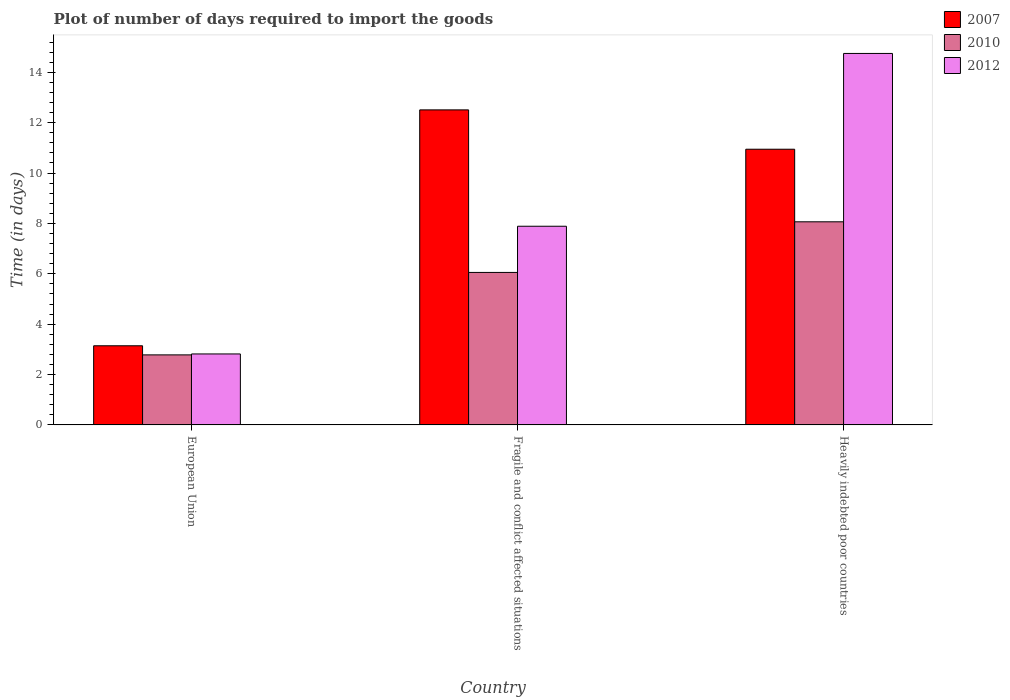Are the number of bars on each tick of the X-axis equal?
Keep it short and to the point. Yes. How many bars are there on the 1st tick from the right?
Offer a terse response. 3. What is the label of the 2nd group of bars from the left?
Make the answer very short. Fragile and conflict affected situations. What is the time required to import goods in 2007 in Heavily indebted poor countries?
Keep it short and to the point. 10.95. Across all countries, what is the maximum time required to import goods in 2012?
Your answer should be very brief. 14.75. Across all countries, what is the minimum time required to import goods in 2012?
Give a very brief answer. 2.82. In which country was the time required to import goods in 2010 maximum?
Ensure brevity in your answer.  Heavily indebted poor countries. What is the total time required to import goods in 2010 in the graph?
Ensure brevity in your answer.  16.9. What is the difference between the time required to import goods in 2012 in European Union and that in Fragile and conflict affected situations?
Provide a short and direct response. -5.07. What is the difference between the time required to import goods in 2012 in Fragile and conflict affected situations and the time required to import goods in 2007 in European Union?
Offer a terse response. 4.75. What is the average time required to import goods in 2007 per country?
Provide a succinct answer. 8.87. What is the difference between the time required to import goods of/in 2012 and time required to import goods of/in 2007 in Heavily indebted poor countries?
Keep it short and to the point. 3.8. What is the ratio of the time required to import goods in 2007 in Fragile and conflict affected situations to that in Heavily indebted poor countries?
Offer a terse response. 1.14. Is the time required to import goods in 2007 in European Union less than that in Fragile and conflict affected situations?
Make the answer very short. Yes. Is the difference between the time required to import goods in 2012 in European Union and Heavily indebted poor countries greater than the difference between the time required to import goods in 2007 in European Union and Heavily indebted poor countries?
Offer a very short reply. No. What is the difference between the highest and the second highest time required to import goods in 2007?
Offer a very short reply. 7.8. What is the difference between the highest and the lowest time required to import goods in 2012?
Your response must be concise. 11.93. In how many countries, is the time required to import goods in 2012 greater than the average time required to import goods in 2012 taken over all countries?
Provide a short and direct response. 1. What does the 1st bar from the left in Heavily indebted poor countries represents?
Provide a succinct answer. 2007. Are the values on the major ticks of Y-axis written in scientific E-notation?
Give a very brief answer. No. Does the graph contain any zero values?
Make the answer very short. No. How many legend labels are there?
Your response must be concise. 3. How are the legend labels stacked?
Provide a short and direct response. Vertical. What is the title of the graph?
Offer a terse response. Plot of number of days required to import the goods. Does "1977" appear as one of the legend labels in the graph?
Your answer should be compact. No. What is the label or title of the Y-axis?
Make the answer very short. Time (in days). What is the Time (in days) in 2007 in European Union?
Keep it short and to the point. 3.14. What is the Time (in days) of 2010 in European Union?
Your response must be concise. 2.78. What is the Time (in days) of 2012 in European Union?
Ensure brevity in your answer.  2.82. What is the Time (in days) in 2007 in Fragile and conflict affected situations?
Provide a short and direct response. 12.51. What is the Time (in days) of 2010 in Fragile and conflict affected situations?
Ensure brevity in your answer.  6.05. What is the Time (in days) in 2012 in Fragile and conflict affected situations?
Keep it short and to the point. 7.89. What is the Time (in days) of 2007 in Heavily indebted poor countries?
Ensure brevity in your answer.  10.95. What is the Time (in days) in 2010 in Heavily indebted poor countries?
Your answer should be compact. 8.06. What is the Time (in days) in 2012 in Heavily indebted poor countries?
Your answer should be very brief. 14.75. Across all countries, what is the maximum Time (in days) in 2007?
Ensure brevity in your answer.  12.51. Across all countries, what is the maximum Time (in days) in 2010?
Keep it short and to the point. 8.06. Across all countries, what is the maximum Time (in days) in 2012?
Your response must be concise. 14.75. Across all countries, what is the minimum Time (in days) in 2007?
Ensure brevity in your answer.  3.14. Across all countries, what is the minimum Time (in days) of 2010?
Ensure brevity in your answer.  2.78. Across all countries, what is the minimum Time (in days) of 2012?
Ensure brevity in your answer.  2.82. What is the total Time (in days) in 2007 in the graph?
Offer a terse response. 26.6. What is the total Time (in days) in 2010 in the graph?
Give a very brief answer. 16.9. What is the total Time (in days) of 2012 in the graph?
Ensure brevity in your answer.  25.46. What is the difference between the Time (in days) of 2007 in European Union and that in Fragile and conflict affected situations?
Your answer should be very brief. -9.37. What is the difference between the Time (in days) in 2010 in European Union and that in Fragile and conflict affected situations?
Offer a terse response. -3.27. What is the difference between the Time (in days) in 2012 in European Union and that in Fragile and conflict affected situations?
Provide a succinct answer. -5.07. What is the difference between the Time (in days) in 2007 in European Union and that in Heavily indebted poor countries?
Provide a succinct answer. -7.8. What is the difference between the Time (in days) in 2010 in European Union and that in Heavily indebted poor countries?
Your answer should be very brief. -5.28. What is the difference between the Time (in days) of 2012 in European Union and that in Heavily indebted poor countries?
Your response must be concise. -11.93. What is the difference between the Time (in days) of 2007 in Fragile and conflict affected situations and that in Heavily indebted poor countries?
Ensure brevity in your answer.  1.56. What is the difference between the Time (in days) of 2010 in Fragile and conflict affected situations and that in Heavily indebted poor countries?
Your answer should be compact. -2.01. What is the difference between the Time (in days) of 2012 in Fragile and conflict affected situations and that in Heavily indebted poor countries?
Give a very brief answer. -6.86. What is the difference between the Time (in days) in 2007 in European Union and the Time (in days) in 2010 in Fragile and conflict affected situations?
Provide a succinct answer. -2.91. What is the difference between the Time (in days) in 2007 in European Union and the Time (in days) in 2012 in Fragile and conflict affected situations?
Your answer should be very brief. -4.75. What is the difference between the Time (in days) in 2010 in European Union and the Time (in days) in 2012 in Fragile and conflict affected situations?
Your response must be concise. -5.11. What is the difference between the Time (in days) of 2007 in European Union and the Time (in days) of 2010 in Heavily indebted poor countries?
Provide a succinct answer. -4.92. What is the difference between the Time (in days) in 2007 in European Union and the Time (in days) in 2012 in Heavily indebted poor countries?
Ensure brevity in your answer.  -11.61. What is the difference between the Time (in days) of 2010 in European Union and the Time (in days) of 2012 in Heavily indebted poor countries?
Your answer should be compact. -11.97. What is the difference between the Time (in days) of 2007 in Fragile and conflict affected situations and the Time (in days) of 2010 in Heavily indebted poor countries?
Keep it short and to the point. 4.44. What is the difference between the Time (in days) of 2007 in Fragile and conflict affected situations and the Time (in days) of 2012 in Heavily indebted poor countries?
Give a very brief answer. -2.24. What is the difference between the Time (in days) of 2010 in Fragile and conflict affected situations and the Time (in days) of 2012 in Heavily indebted poor countries?
Keep it short and to the point. -8.7. What is the average Time (in days) in 2007 per country?
Offer a very short reply. 8.87. What is the average Time (in days) of 2010 per country?
Give a very brief answer. 5.63. What is the average Time (in days) in 2012 per country?
Offer a very short reply. 8.49. What is the difference between the Time (in days) of 2007 and Time (in days) of 2010 in European Union?
Your answer should be compact. 0.36. What is the difference between the Time (in days) of 2007 and Time (in days) of 2012 in European Union?
Keep it short and to the point. 0.32. What is the difference between the Time (in days) of 2010 and Time (in days) of 2012 in European Union?
Provide a succinct answer. -0.04. What is the difference between the Time (in days) of 2007 and Time (in days) of 2010 in Fragile and conflict affected situations?
Offer a terse response. 6.45. What is the difference between the Time (in days) in 2007 and Time (in days) in 2012 in Fragile and conflict affected situations?
Keep it short and to the point. 4.62. What is the difference between the Time (in days) of 2010 and Time (in days) of 2012 in Fragile and conflict affected situations?
Offer a very short reply. -1.83. What is the difference between the Time (in days) in 2007 and Time (in days) in 2010 in Heavily indebted poor countries?
Your answer should be very brief. 2.88. What is the difference between the Time (in days) in 2007 and Time (in days) in 2012 in Heavily indebted poor countries?
Provide a short and direct response. -3.8. What is the difference between the Time (in days) in 2010 and Time (in days) in 2012 in Heavily indebted poor countries?
Your answer should be compact. -6.69. What is the ratio of the Time (in days) of 2007 in European Union to that in Fragile and conflict affected situations?
Your answer should be very brief. 0.25. What is the ratio of the Time (in days) of 2010 in European Union to that in Fragile and conflict affected situations?
Offer a terse response. 0.46. What is the ratio of the Time (in days) of 2012 in European Union to that in Fragile and conflict affected situations?
Your answer should be compact. 0.36. What is the ratio of the Time (in days) of 2007 in European Union to that in Heavily indebted poor countries?
Give a very brief answer. 0.29. What is the ratio of the Time (in days) of 2010 in European Union to that in Heavily indebted poor countries?
Offer a terse response. 0.34. What is the ratio of the Time (in days) in 2012 in European Union to that in Heavily indebted poor countries?
Your response must be concise. 0.19. What is the ratio of the Time (in days) of 2007 in Fragile and conflict affected situations to that in Heavily indebted poor countries?
Your response must be concise. 1.14. What is the ratio of the Time (in days) of 2010 in Fragile and conflict affected situations to that in Heavily indebted poor countries?
Provide a short and direct response. 0.75. What is the ratio of the Time (in days) of 2012 in Fragile and conflict affected situations to that in Heavily indebted poor countries?
Your answer should be very brief. 0.53. What is the difference between the highest and the second highest Time (in days) in 2007?
Provide a succinct answer. 1.56. What is the difference between the highest and the second highest Time (in days) in 2010?
Make the answer very short. 2.01. What is the difference between the highest and the second highest Time (in days) of 2012?
Provide a succinct answer. 6.86. What is the difference between the highest and the lowest Time (in days) in 2007?
Your response must be concise. 9.37. What is the difference between the highest and the lowest Time (in days) of 2010?
Offer a very short reply. 5.28. What is the difference between the highest and the lowest Time (in days) of 2012?
Ensure brevity in your answer.  11.93. 